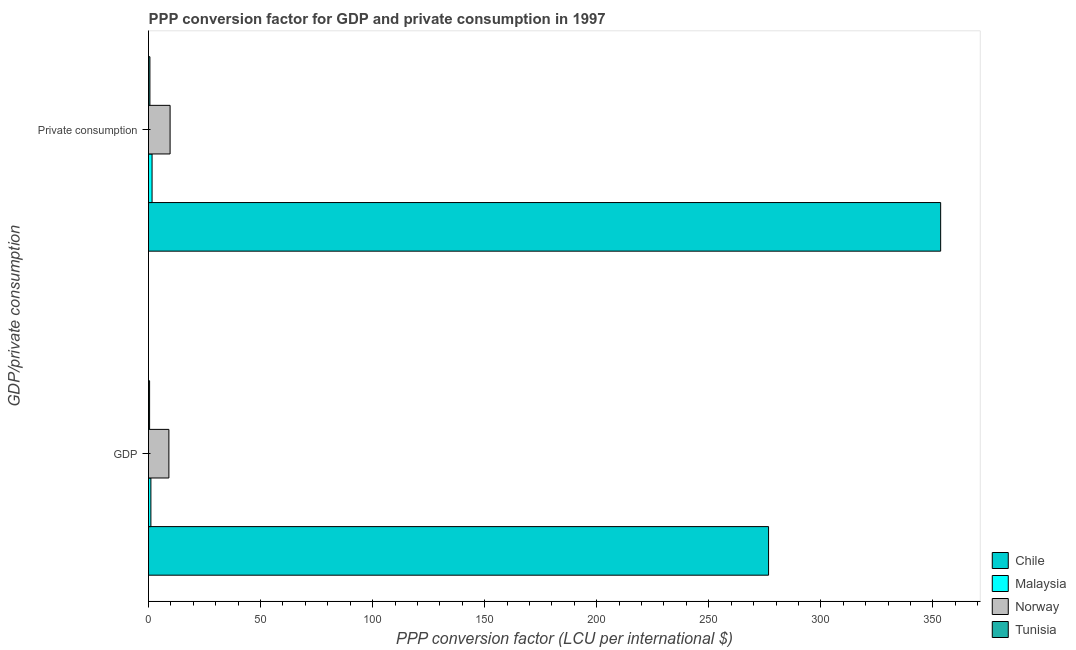How many different coloured bars are there?
Offer a terse response. 4. How many groups of bars are there?
Provide a succinct answer. 2. Are the number of bars per tick equal to the number of legend labels?
Offer a very short reply. Yes. How many bars are there on the 2nd tick from the top?
Your response must be concise. 4. How many bars are there on the 1st tick from the bottom?
Offer a terse response. 4. What is the label of the 1st group of bars from the top?
Ensure brevity in your answer.   Private consumption. What is the ppp conversion factor for gdp in Malaysia?
Give a very brief answer. 1.06. Across all countries, what is the maximum ppp conversion factor for gdp?
Ensure brevity in your answer.  276.67. Across all countries, what is the minimum ppp conversion factor for gdp?
Provide a short and direct response. 0.48. In which country was the ppp conversion factor for private consumption maximum?
Your answer should be very brief. Chile. In which country was the ppp conversion factor for private consumption minimum?
Your response must be concise. Tunisia. What is the total ppp conversion factor for gdp in the graph?
Provide a short and direct response. 287.3. What is the difference between the ppp conversion factor for gdp in Tunisia and that in Malaysia?
Provide a short and direct response. -0.58. What is the difference between the ppp conversion factor for gdp in Norway and the ppp conversion factor for private consumption in Chile?
Keep it short and to the point. -344.37. What is the average ppp conversion factor for private consumption per country?
Make the answer very short. 91.32. What is the difference between the ppp conversion factor for private consumption and ppp conversion factor for gdp in Norway?
Your answer should be compact. 0.54. What is the ratio of the ppp conversion factor for private consumption in Chile to that in Tunisia?
Your answer should be very brief. 570. Is the ppp conversion factor for gdp in Tunisia less than that in Malaysia?
Make the answer very short. Yes. In how many countries, is the ppp conversion factor for gdp greater than the average ppp conversion factor for gdp taken over all countries?
Offer a terse response. 1. What does the 2nd bar from the bottom in  Private consumption represents?
Keep it short and to the point. Malaysia. Are all the bars in the graph horizontal?
Keep it short and to the point. Yes. How many countries are there in the graph?
Your response must be concise. 4. Are the values on the major ticks of X-axis written in scientific E-notation?
Make the answer very short. No. Does the graph contain any zero values?
Keep it short and to the point. No. How many legend labels are there?
Your answer should be compact. 4. How are the legend labels stacked?
Give a very brief answer. Vertical. What is the title of the graph?
Provide a succinct answer. PPP conversion factor for GDP and private consumption in 1997. Does "Guinea-Bissau" appear as one of the legend labels in the graph?
Keep it short and to the point. No. What is the label or title of the X-axis?
Give a very brief answer. PPP conversion factor (LCU per international $). What is the label or title of the Y-axis?
Offer a very short reply. GDP/private consumption. What is the PPP conversion factor (LCU per international $) of Chile in GDP?
Your answer should be compact. 276.67. What is the PPP conversion factor (LCU per international $) in Malaysia in GDP?
Offer a terse response. 1.06. What is the PPP conversion factor (LCU per international $) in Norway in GDP?
Provide a short and direct response. 9.09. What is the PPP conversion factor (LCU per international $) of Tunisia in GDP?
Your answer should be compact. 0.48. What is the PPP conversion factor (LCU per international $) in Chile in  Private consumption?
Your response must be concise. 353.46. What is the PPP conversion factor (LCU per international $) in Malaysia in  Private consumption?
Give a very brief answer. 1.58. What is the PPP conversion factor (LCU per international $) in Norway in  Private consumption?
Provide a short and direct response. 9.63. What is the PPP conversion factor (LCU per international $) in Tunisia in  Private consumption?
Your answer should be compact. 0.62. Across all GDP/private consumption, what is the maximum PPP conversion factor (LCU per international $) in Chile?
Make the answer very short. 353.46. Across all GDP/private consumption, what is the maximum PPP conversion factor (LCU per international $) of Malaysia?
Your answer should be very brief. 1.58. Across all GDP/private consumption, what is the maximum PPP conversion factor (LCU per international $) in Norway?
Make the answer very short. 9.63. Across all GDP/private consumption, what is the maximum PPP conversion factor (LCU per international $) of Tunisia?
Provide a succinct answer. 0.62. Across all GDP/private consumption, what is the minimum PPP conversion factor (LCU per international $) in Chile?
Ensure brevity in your answer.  276.67. Across all GDP/private consumption, what is the minimum PPP conversion factor (LCU per international $) of Malaysia?
Your response must be concise. 1.06. Across all GDP/private consumption, what is the minimum PPP conversion factor (LCU per international $) in Norway?
Offer a very short reply. 9.09. Across all GDP/private consumption, what is the minimum PPP conversion factor (LCU per international $) of Tunisia?
Make the answer very short. 0.48. What is the total PPP conversion factor (LCU per international $) of Chile in the graph?
Give a very brief answer. 630.14. What is the total PPP conversion factor (LCU per international $) of Malaysia in the graph?
Offer a very short reply. 2.63. What is the total PPP conversion factor (LCU per international $) in Norway in the graph?
Provide a succinct answer. 18.72. What is the total PPP conversion factor (LCU per international $) in Tunisia in the graph?
Give a very brief answer. 1.1. What is the difference between the PPP conversion factor (LCU per international $) of Chile in GDP and that in  Private consumption?
Ensure brevity in your answer.  -76.79. What is the difference between the PPP conversion factor (LCU per international $) of Malaysia in GDP and that in  Private consumption?
Offer a very short reply. -0.52. What is the difference between the PPP conversion factor (LCU per international $) of Norway in GDP and that in  Private consumption?
Your answer should be very brief. -0.54. What is the difference between the PPP conversion factor (LCU per international $) in Tunisia in GDP and that in  Private consumption?
Keep it short and to the point. -0.14. What is the difference between the PPP conversion factor (LCU per international $) of Chile in GDP and the PPP conversion factor (LCU per international $) of Malaysia in  Private consumption?
Provide a succinct answer. 275.1. What is the difference between the PPP conversion factor (LCU per international $) of Chile in GDP and the PPP conversion factor (LCU per international $) of Norway in  Private consumption?
Provide a succinct answer. 267.05. What is the difference between the PPP conversion factor (LCU per international $) of Chile in GDP and the PPP conversion factor (LCU per international $) of Tunisia in  Private consumption?
Your answer should be compact. 276.05. What is the difference between the PPP conversion factor (LCU per international $) in Malaysia in GDP and the PPP conversion factor (LCU per international $) in Norway in  Private consumption?
Offer a terse response. -8.57. What is the difference between the PPP conversion factor (LCU per international $) in Malaysia in GDP and the PPP conversion factor (LCU per international $) in Tunisia in  Private consumption?
Provide a succinct answer. 0.44. What is the difference between the PPP conversion factor (LCU per international $) in Norway in GDP and the PPP conversion factor (LCU per international $) in Tunisia in  Private consumption?
Provide a succinct answer. 8.47. What is the average PPP conversion factor (LCU per international $) of Chile per GDP/private consumption?
Your answer should be compact. 315.07. What is the average PPP conversion factor (LCU per international $) in Malaysia per GDP/private consumption?
Keep it short and to the point. 1.32. What is the average PPP conversion factor (LCU per international $) in Norway per GDP/private consumption?
Offer a very short reply. 9.36. What is the average PPP conversion factor (LCU per international $) of Tunisia per GDP/private consumption?
Keep it short and to the point. 0.55. What is the difference between the PPP conversion factor (LCU per international $) in Chile and PPP conversion factor (LCU per international $) in Malaysia in GDP?
Your answer should be compact. 275.62. What is the difference between the PPP conversion factor (LCU per international $) of Chile and PPP conversion factor (LCU per international $) of Norway in GDP?
Keep it short and to the point. 267.58. What is the difference between the PPP conversion factor (LCU per international $) in Chile and PPP conversion factor (LCU per international $) in Tunisia in GDP?
Your answer should be compact. 276.19. What is the difference between the PPP conversion factor (LCU per international $) in Malaysia and PPP conversion factor (LCU per international $) in Norway in GDP?
Keep it short and to the point. -8.04. What is the difference between the PPP conversion factor (LCU per international $) in Malaysia and PPP conversion factor (LCU per international $) in Tunisia in GDP?
Keep it short and to the point. 0.58. What is the difference between the PPP conversion factor (LCU per international $) of Norway and PPP conversion factor (LCU per international $) of Tunisia in GDP?
Offer a terse response. 8.61. What is the difference between the PPP conversion factor (LCU per international $) in Chile and PPP conversion factor (LCU per international $) in Malaysia in  Private consumption?
Offer a very short reply. 351.88. What is the difference between the PPP conversion factor (LCU per international $) of Chile and PPP conversion factor (LCU per international $) of Norway in  Private consumption?
Provide a short and direct response. 343.83. What is the difference between the PPP conversion factor (LCU per international $) of Chile and PPP conversion factor (LCU per international $) of Tunisia in  Private consumption?
Give a very brief answer. 352.84. What is the difference between the PPP conversion factor (LCU per international $) in Malaysia and PPP conversion factor (LCU per international $) in Norway in  Private consumption?
Ensure brevity in your answer.  -8.05. What is the difference between the PPP conversion factor (LCU per international $) in Malaysia and PPP conversion factor (LCU per international $) in Tunisia in  Private consumption?
Provide a succinct answer. 0.96. What is the difference between the PPP conversion factor (LCU per international $) in Norway and PPP conversion factor (LCU per international $) in Tunisia in  Private consumption?
Your response must be concise. 9.01. What is the ratio of the PPP conversion factor (LCU per international $) in Chile in GDP to that in  Private consumption?
Make the answer very short. 0.78. What is the ratio of the PPP conversion factor (LCU per international $) of Malaysia in GDP to that in  Private consumption?
Your answer should be compact. 0.67. What is the ratio of the PPP conversion factor (LCU per international $) of Norway in GDP to that in  Private consumption?
Provide a succinct answer. 0.94. What is the ratio of the PPP conversion factor (LCU per international $) in Tunisia in GDP to that in  Private consumption?
Your answer should be very brief. 0.78. What is the difference between the highest and the second highest PPP conversion factor (LCU per international $) in Chile?
Your response must be concise. 76.79. What is the difference between the highest and the second highest PPP conversion factor (LCU per international $) in Malaysia?
Ensure brevity in your answer.  0.52. What is the difference between the highest and the second highest PPP conversion factor (LCU per international $) of Norway?
Provide a short and direct response. 0.54. What is the difference between the highest and the second highest PPP conversion factor (LCU per international $) of Tunisia?
Make the answer very short. 0.14. What is the difference between the highest and the lowest PPP conversion factor (LCU per international $) in Chile?
Your answer should be compact. 76.79. What is the difference between the highest and the lowest PPP conversion factor (LCU per international $) of Malaysia?
Provide a short and direct response. 0.52. What is the difference between the highest and the lowest PPP conversion factor (LCU per international $) of Norway?
Your response must be concise. 0.54. What is the difference between the highest and the lowest PPP conversion factor (LCU per international $) of Tunisia?
Your answer should be very brief. 0.14. 